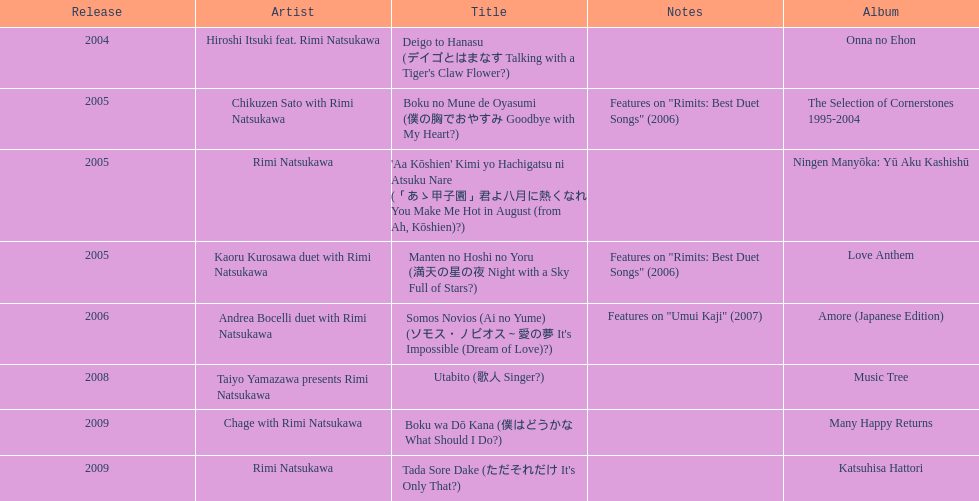When was the first title made available? 2004. 